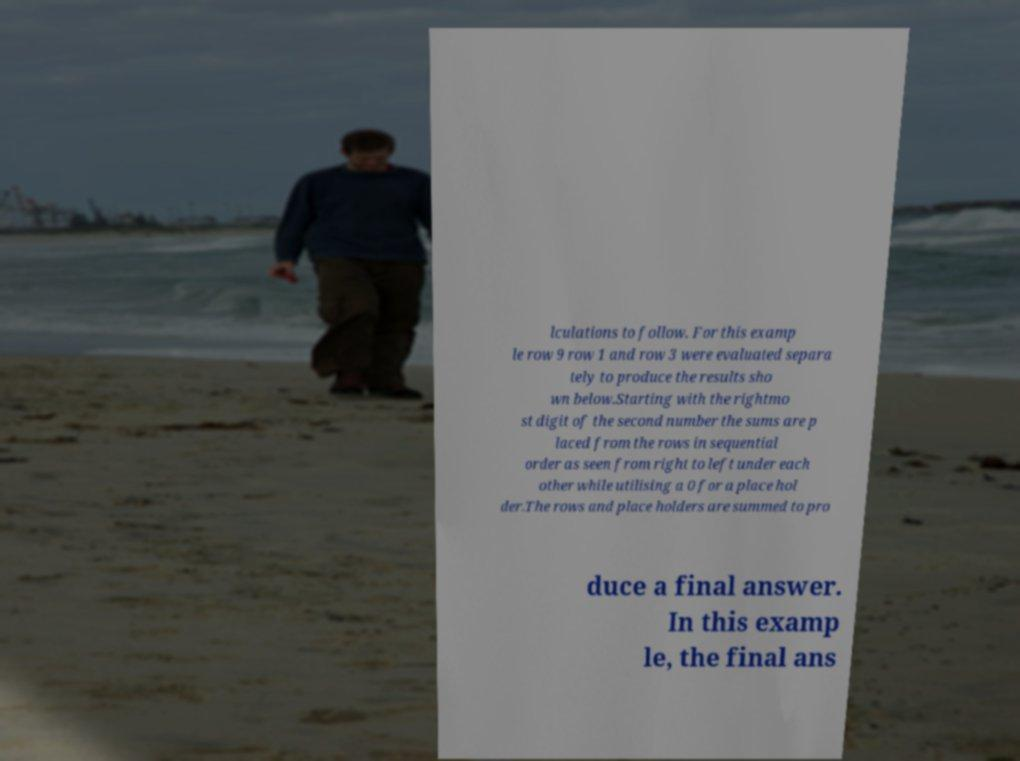For documentation purposes, I need the text within this image transcribed. Could you provide that? lculations to follow. For this examp le row 9 row 1 and row 3 were evaluated separa tely to produce the results sho wn below.Starting with the rightmo st digit of the second number the sums are p laced from the rows in sequential order as seen from right to left under each other while utilising a 0 for a place hol der.The rows and place holders are summed to pro duce a final answer. In this examp le, the final ans 